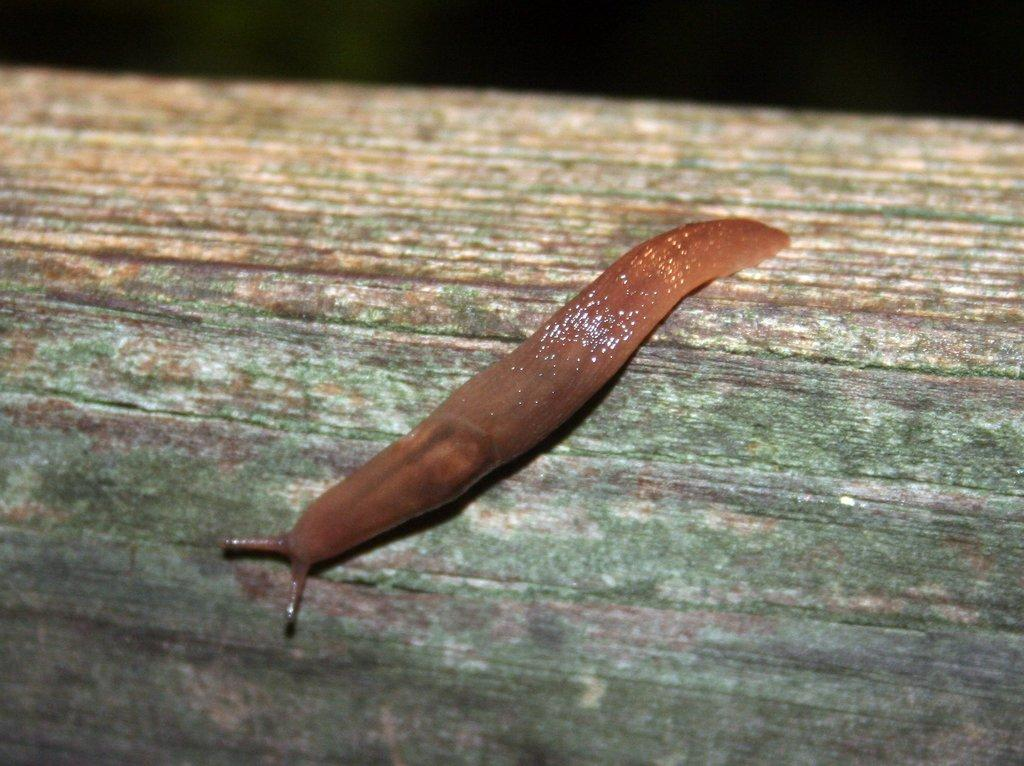What is the main subject of the image? The main subject of the image is a leech. Where is the leech located in the image? The leech is on a wooden surface. What can be observed about the lighting in the image? The top of the image is dark. What type of substance is being used by the mice in the image? There are no mice present in the image, so it is not possible to determine what type of substance they might be using. 